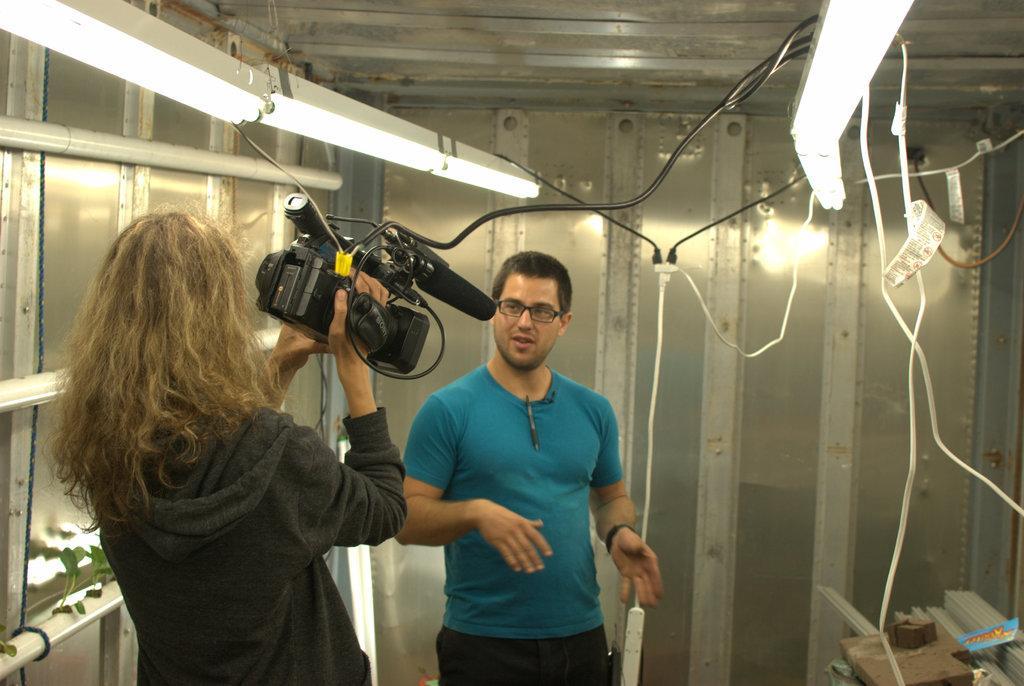How would you summarize this image in a sentence or two? In this picture there is a girl on the left side of the image, by holding a video recorder and there is a man in front of her and there are lights at the top side of the image and there are wires in the image, there is a rack at the bottom side of the image, on which there are boxes. 